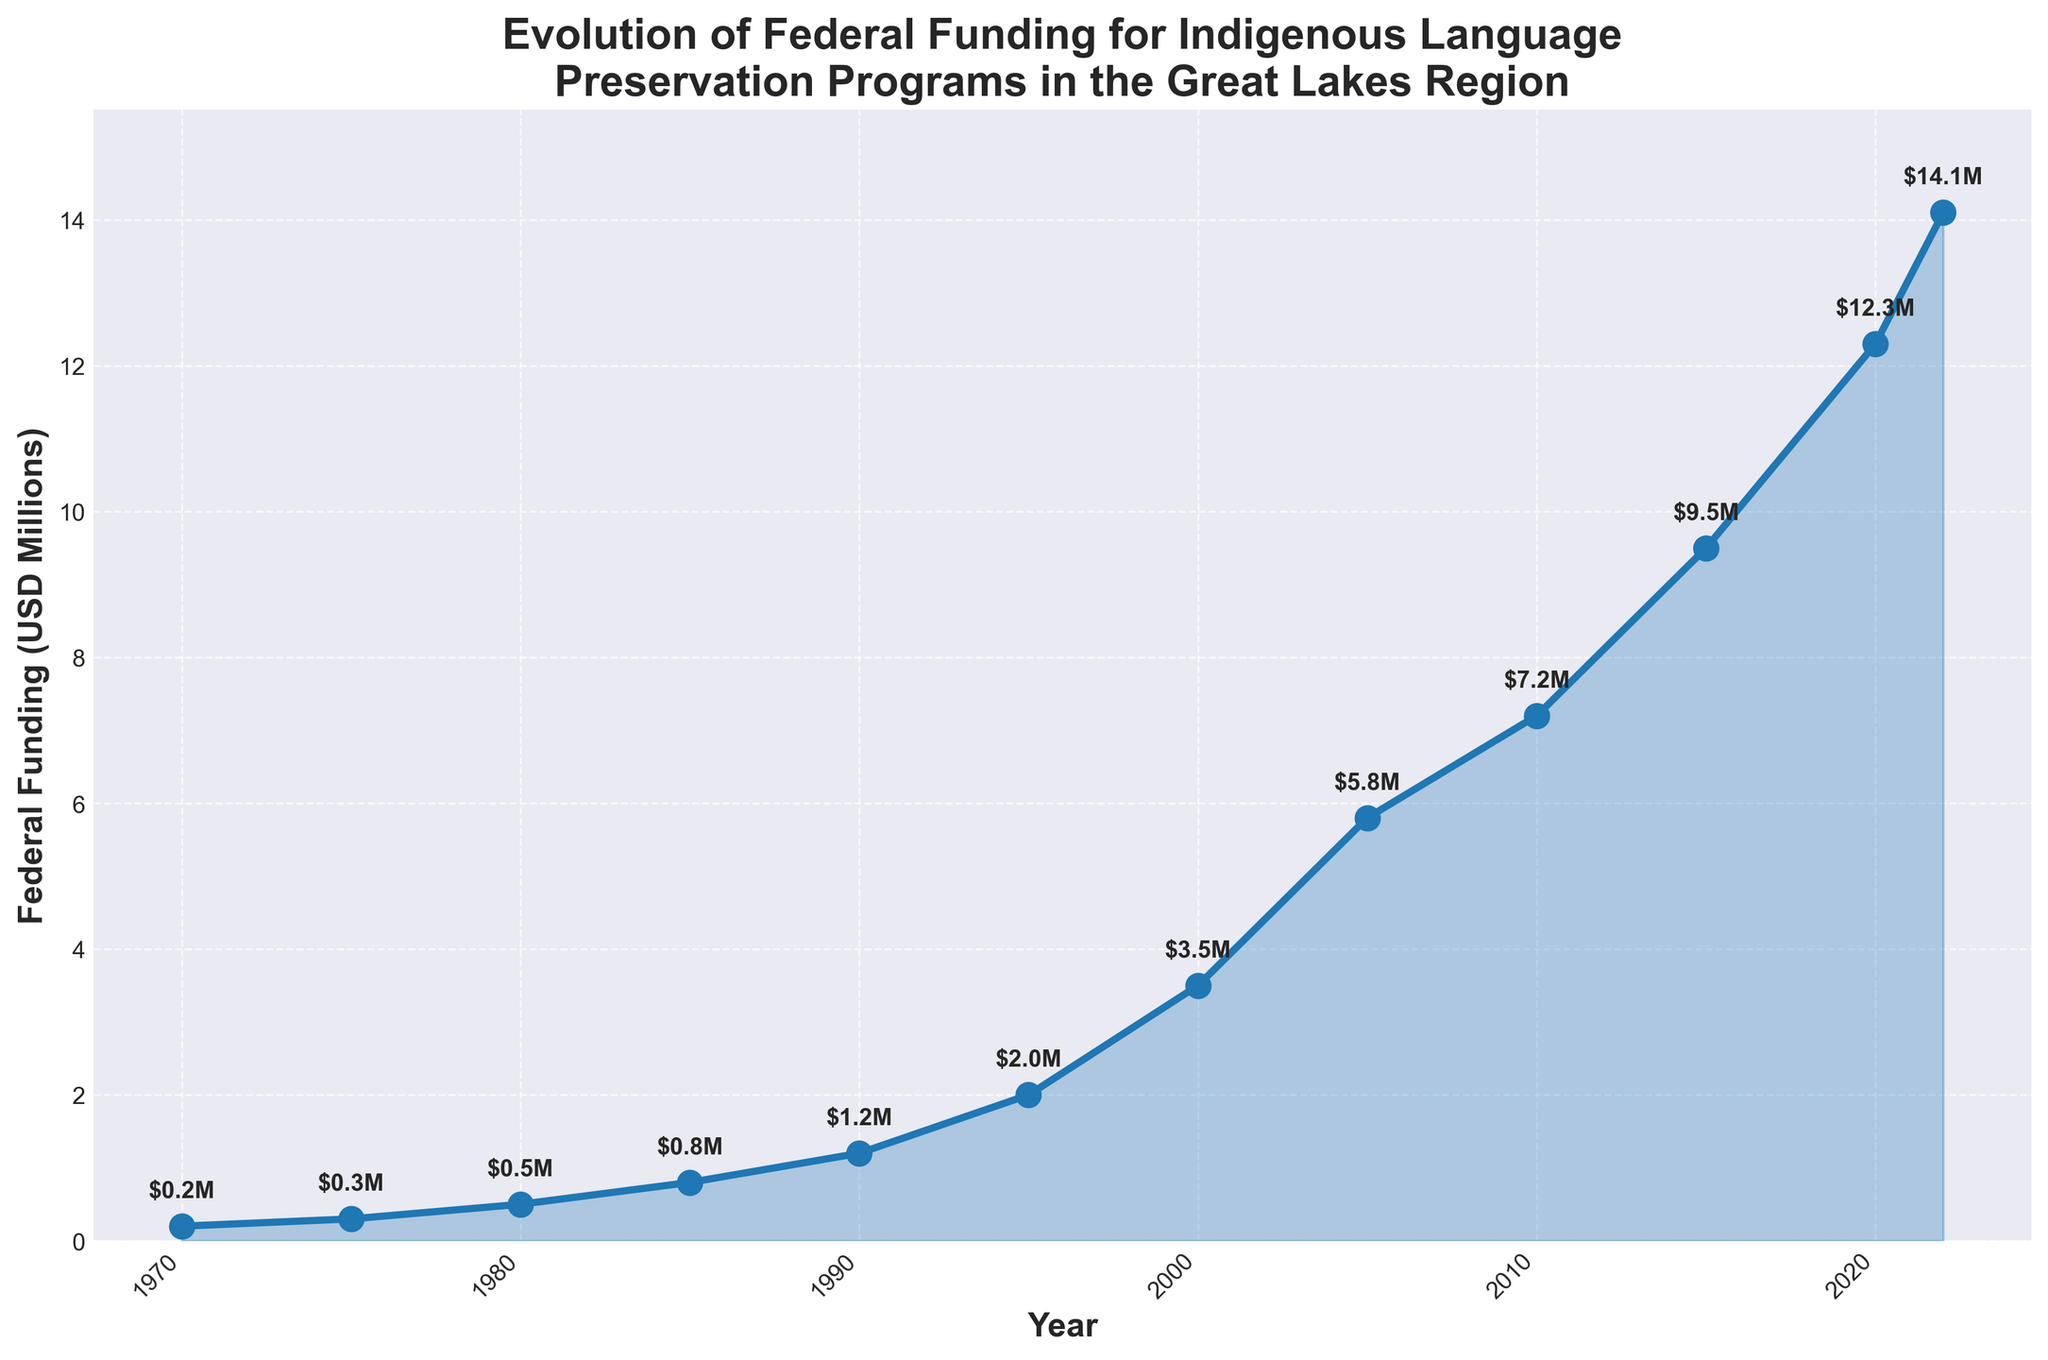What was the federal funding in 1985? The plot shows a data point for each year. Locate the point corresponding to 1985 and read the funding value.
Answer: 0.8 million USD Between which years did the federal funding increase the most? Identify the steepest segment of the line plot. The sharpest increase is between 2000 and 2005.
Answer: 2000 and 2005 What was the total federal funding provided between 1970 and 1980? Sum the funding values for 1970, 1975, and 1980. The values are 0.2, 0.3, and 0.5, respectively. Sum is 0.2 + 0.3 + 0.5 = 1.0 million USD.
Answer: 1.0 million USD What is the average federal funding per period between 2000 and 2022? Identify the funding values for 2000, 2005, 2010, 2015, 2020, and 2022. Sum these values: 3.5 + 5.8 + 7.2 + 9.5 + 12.3 + 14.1 = 52.4 million USD. Divide this sum by the number of periods: 52.4 / 6 = 8.73 million USD (rounded to 2 decimal places).
Answer: 8.73 million USD Does the federal funding ever decrease across the years displayed? Observing the plot, the funding consistently increases over the years, with no decline at any point.
Answer: No What is the increase in funding from 1970 to 2022? Subtract the 1970 funding from the 2022 funding: 14.1 - 0.2 = 13.9 million USD.
Answer: 13.9 million USD Which year had the highest federal funding? The highest point on the plot corresponds to the year 2022.
Answer: 2022 By how much did the federal funding increase from 1990 to 1995? Subtract the 1990 funding from the 1995 funding: 2.0 - 1.2 = 0.8 million USD.
Answer: 0.8 million USD How many years did it take for the federal funding to double from 2000's value? The funding in 2000 was 3.5 million USD. Doubling this value gives 7.0 million USD. Look for the year when funding reaches or exceeds 7.0 million USD, which occurs in 2010. The time taken is 2010 - 2000 = 10 years.
Answer: 10 years 